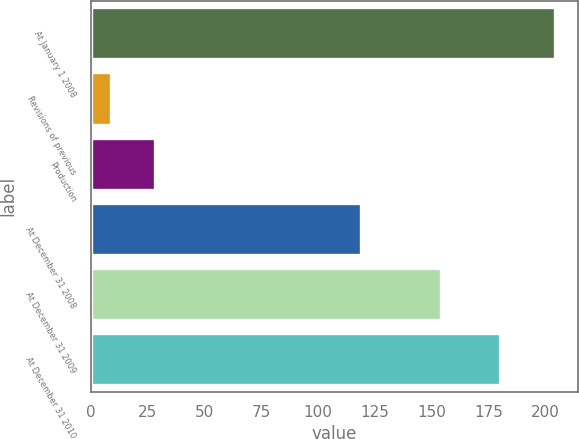Convert chart. <chart><loc_0><loc_0><loc_500><loc_500><bar_chart><fcel>At January 1 2008<fcel>Revisions of previous<fcel>Production<fcel>At December 31 2008<fcel>At December 31 2009<fcel>At December 31 2010<nl><fcel>204<fcel>9<fcel>28.5<fcel>119<fcel>154<fcel>180<nl></chart> 